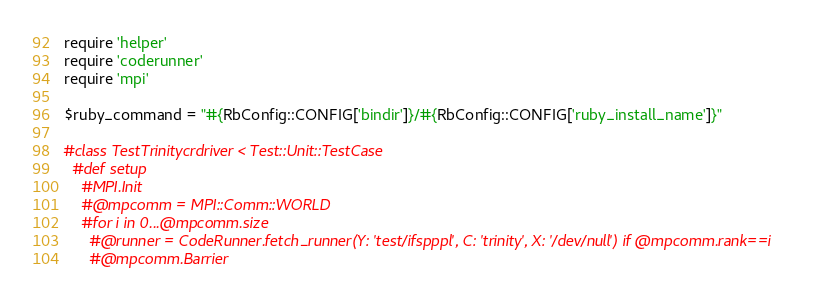Convert code to text. <code><loc_0><loc_0><loc_500><loc_500><_Ruby_>require 'helper'
require 'coderunner'
require 'mpi'

$ruby_command = "#{RbConfig::CONFIG['bindir']}/#{RbConfig::CONFIG['ruby_install_name']}"

#class TestTrinitycrdriver < Test::Unit::TestCase
  #def setup
    #MPI.Init
    #@mpcomm = MPI::Comm::WORLD
    #for i in 0...@mpcomm.size
      #@runner = CodeRunner.fetch_runner(Y: 'test/ifspppl', C: 'trinity', X: '/dev/null') if @mpcomm.rank==i
      #@mpcomm.Barrier</code> 